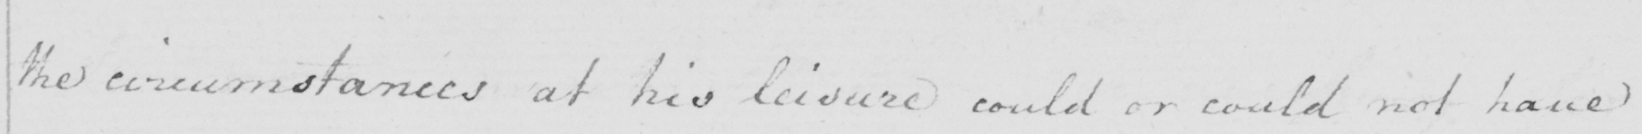What text is written in this handwritten line? the circumstances at his leisure could or could not have 